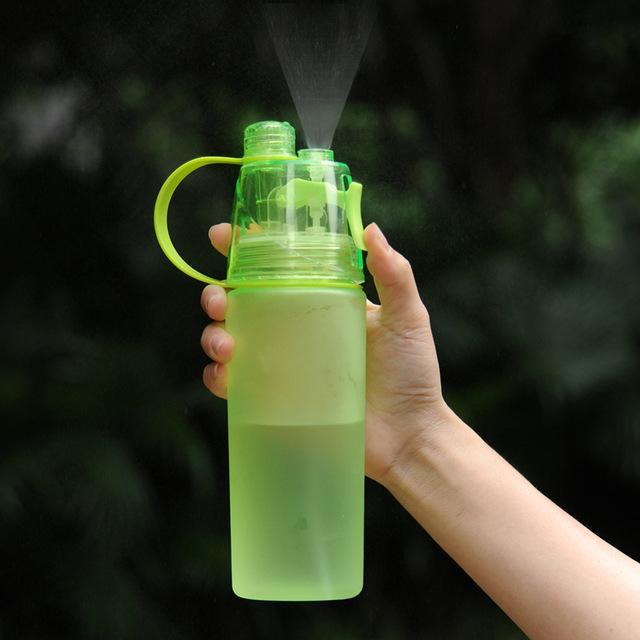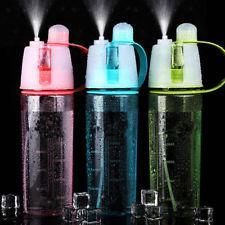The first image is the image on the left, the second image is the image on the right. Given the left and right images, does the statement "The left image has three water bottles" hold true? Answer yes or no. No. The first image is the image on the left, the second image is the image on the right. Assess this claim about the two images: "The left and right image contains four water bottle misters with at two green bottles.". Correct or not? Answer yes or no. Yes. 